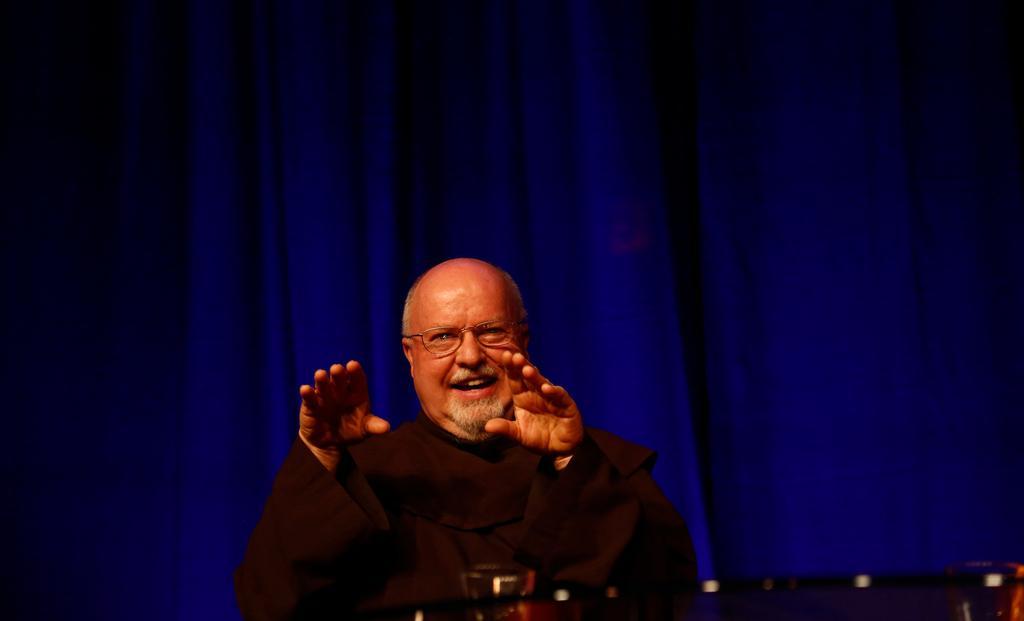Please provide a concise description of this image. In this image we can see a person standing, in front of him we can see a table and in the background we can see a curtain. 